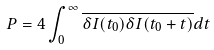<formula> <loc_0><loc_0><loc_500><loc_500>P = 4 \int _ { 0 } ^ { \infty } \overline { \delta I ( t _ { 0 } ) \delta I ( t _ { 0 } + t ) } d t</formula> 